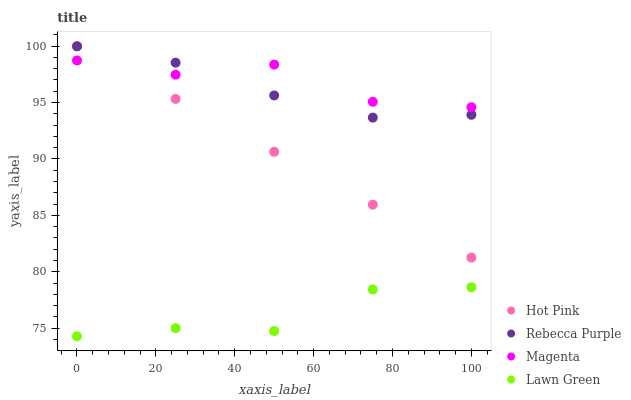Does Lawn Green have the minimum area under the curve?
Answer yes or no. Yes. Does Magenta have the maximum area under the curve?
Answer yes or no. Yes. Does Hot Pink have the minimum area under the curve?
Answer yes or no. No. Does Hot Pink have the maximum area under the curve?
Answer yes or no. No. Is Hot Pink the smoothest?
Answer yes or no. Yes. Is Magenta the roughest?
Answer yes or no. Yes. Is Magenta the smoothest?
Answer yes or no. No. Is Hot Pink the roughest?
Answer yes or no. No. Does Lawn Green have the lowest value?
Answer yes or no. Yes. Does Hot Pink have the lowest value?
Answer yes or no. No. Does Hot Pink have the highest value?
Answer yes or no. Yes. Does Magenta have the highest value?
Answer yes or no. No. Is Lawn Green less than Magenta?
Answer yes or no. Yes. Is Hot Pink greater than Lawn Green?
Answer yes or no. Yes. Does Hot Pink intersect Magenta?
Answer yes or no. Yes. Is Hot Pink less than Magenta?
Answer yes or no. No. Is Hot Pink greater than Magenta?
Answer yes or no. No. Does Lawn Green intersect Magenta?
Answer yes or no. No. 